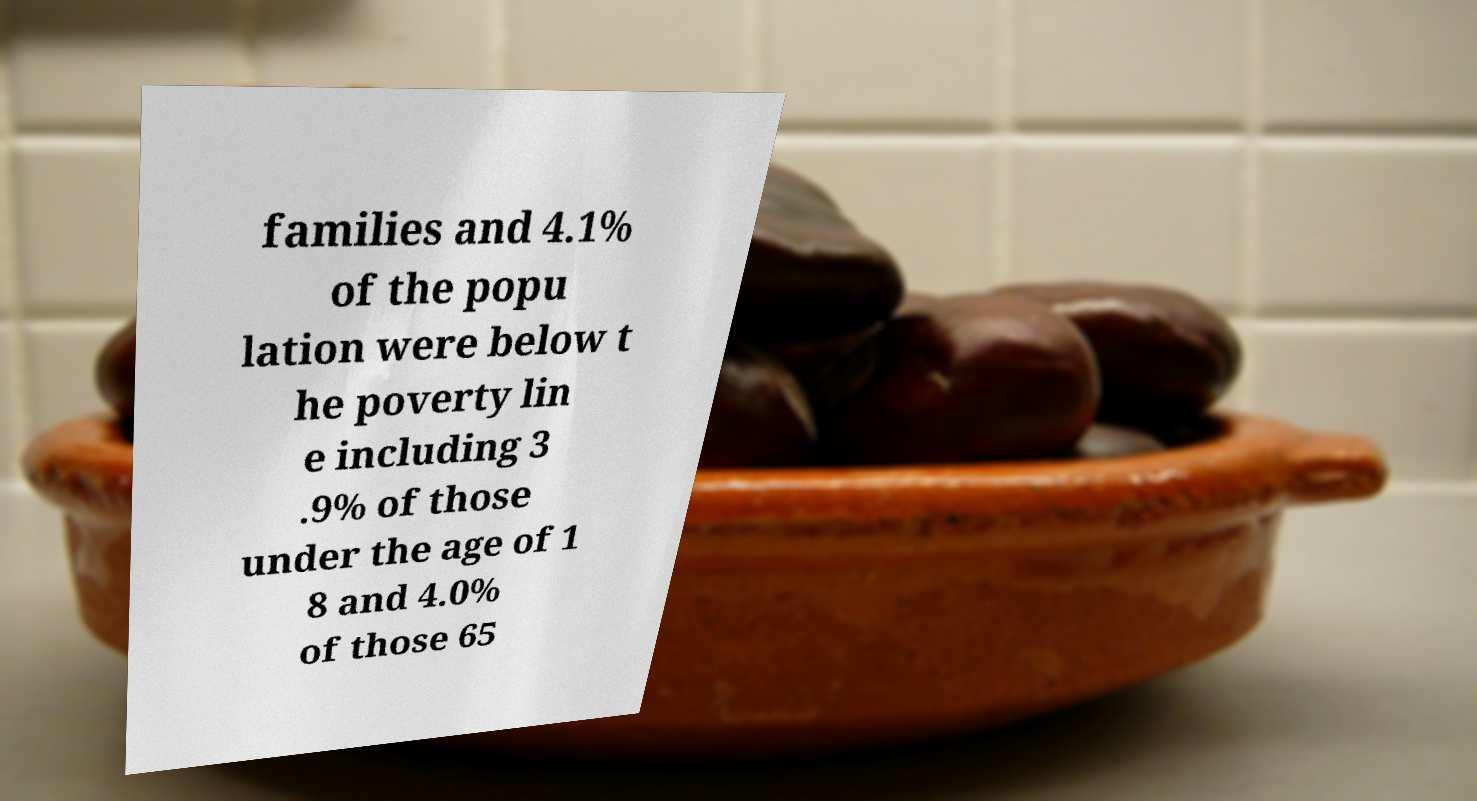There's text embedded in this image that I need extracted. Can you transcribe it verbatim? families and 4.1% of the popu lation were below t he poverty lin e including 3 .9% of those under the age of 1 8 and 4.0% of those 65 